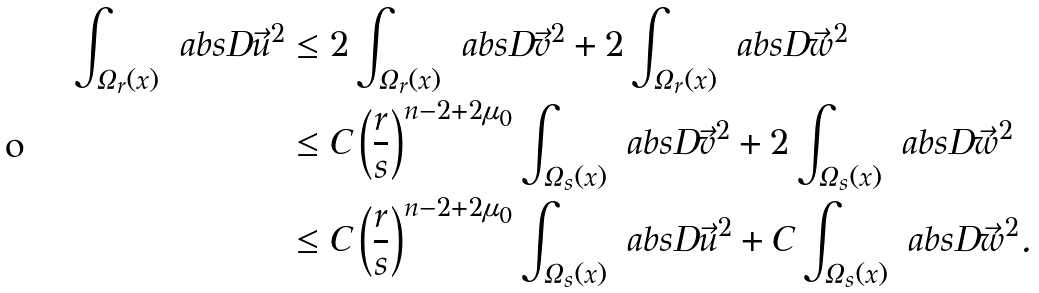Convert formula to latex. <formula><loc_0><loc_0><loc_500><loc_500>\int _ { \Omega _ { r } ( x ) } \ a b s { D \vec { u } } ^ { 2 } & \leq 2 \int _ { \Omega _ { r } ( x ) } \ a b s { D \vec { v } } ^ { 2 } + 2 \int _ { \Omega _ { r } ( x ) } \ a b s { D \vec { w } } ^ { 2 } \\ & \leq C \left ( \frac { r } { s } \right ) ^ { n - 2 + 2 \mu _ { 0 } } \int _ { \Omega _ { s } ( x ) } \ a b s { D \vec { v } } ^ { 2 } + 2 \int _ { \Omega _ { s } ( x ) } \ a b s { D \vec { w } } ^ { 2 } \\ & \leq C \left ( \frac { r } { s } \right ) ^ { n - 2 + 2 \mu _ { 0 } } \int _ { \Omega _ { s } ( x ) } \ a b s { D \vec { u } } ^ { 2 } + C \int _ { \Omega _ { s } ( x ) } \ a b s { D \vec { w } } ^ { 2 } .</formula> 